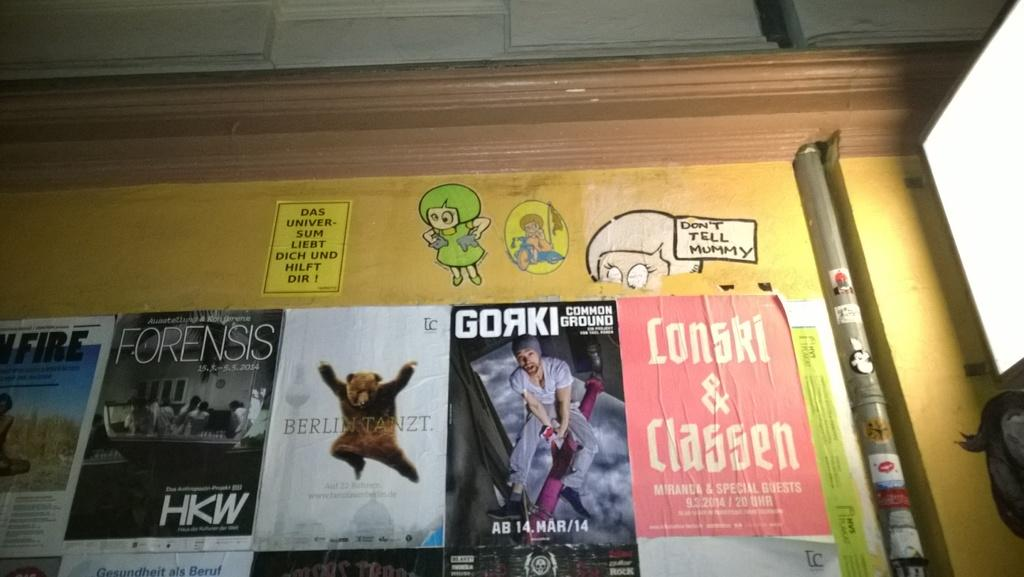<image>
Relay a brief, clear account of the picture shown. The inside of a drawer with a sticker that says Gorki. 